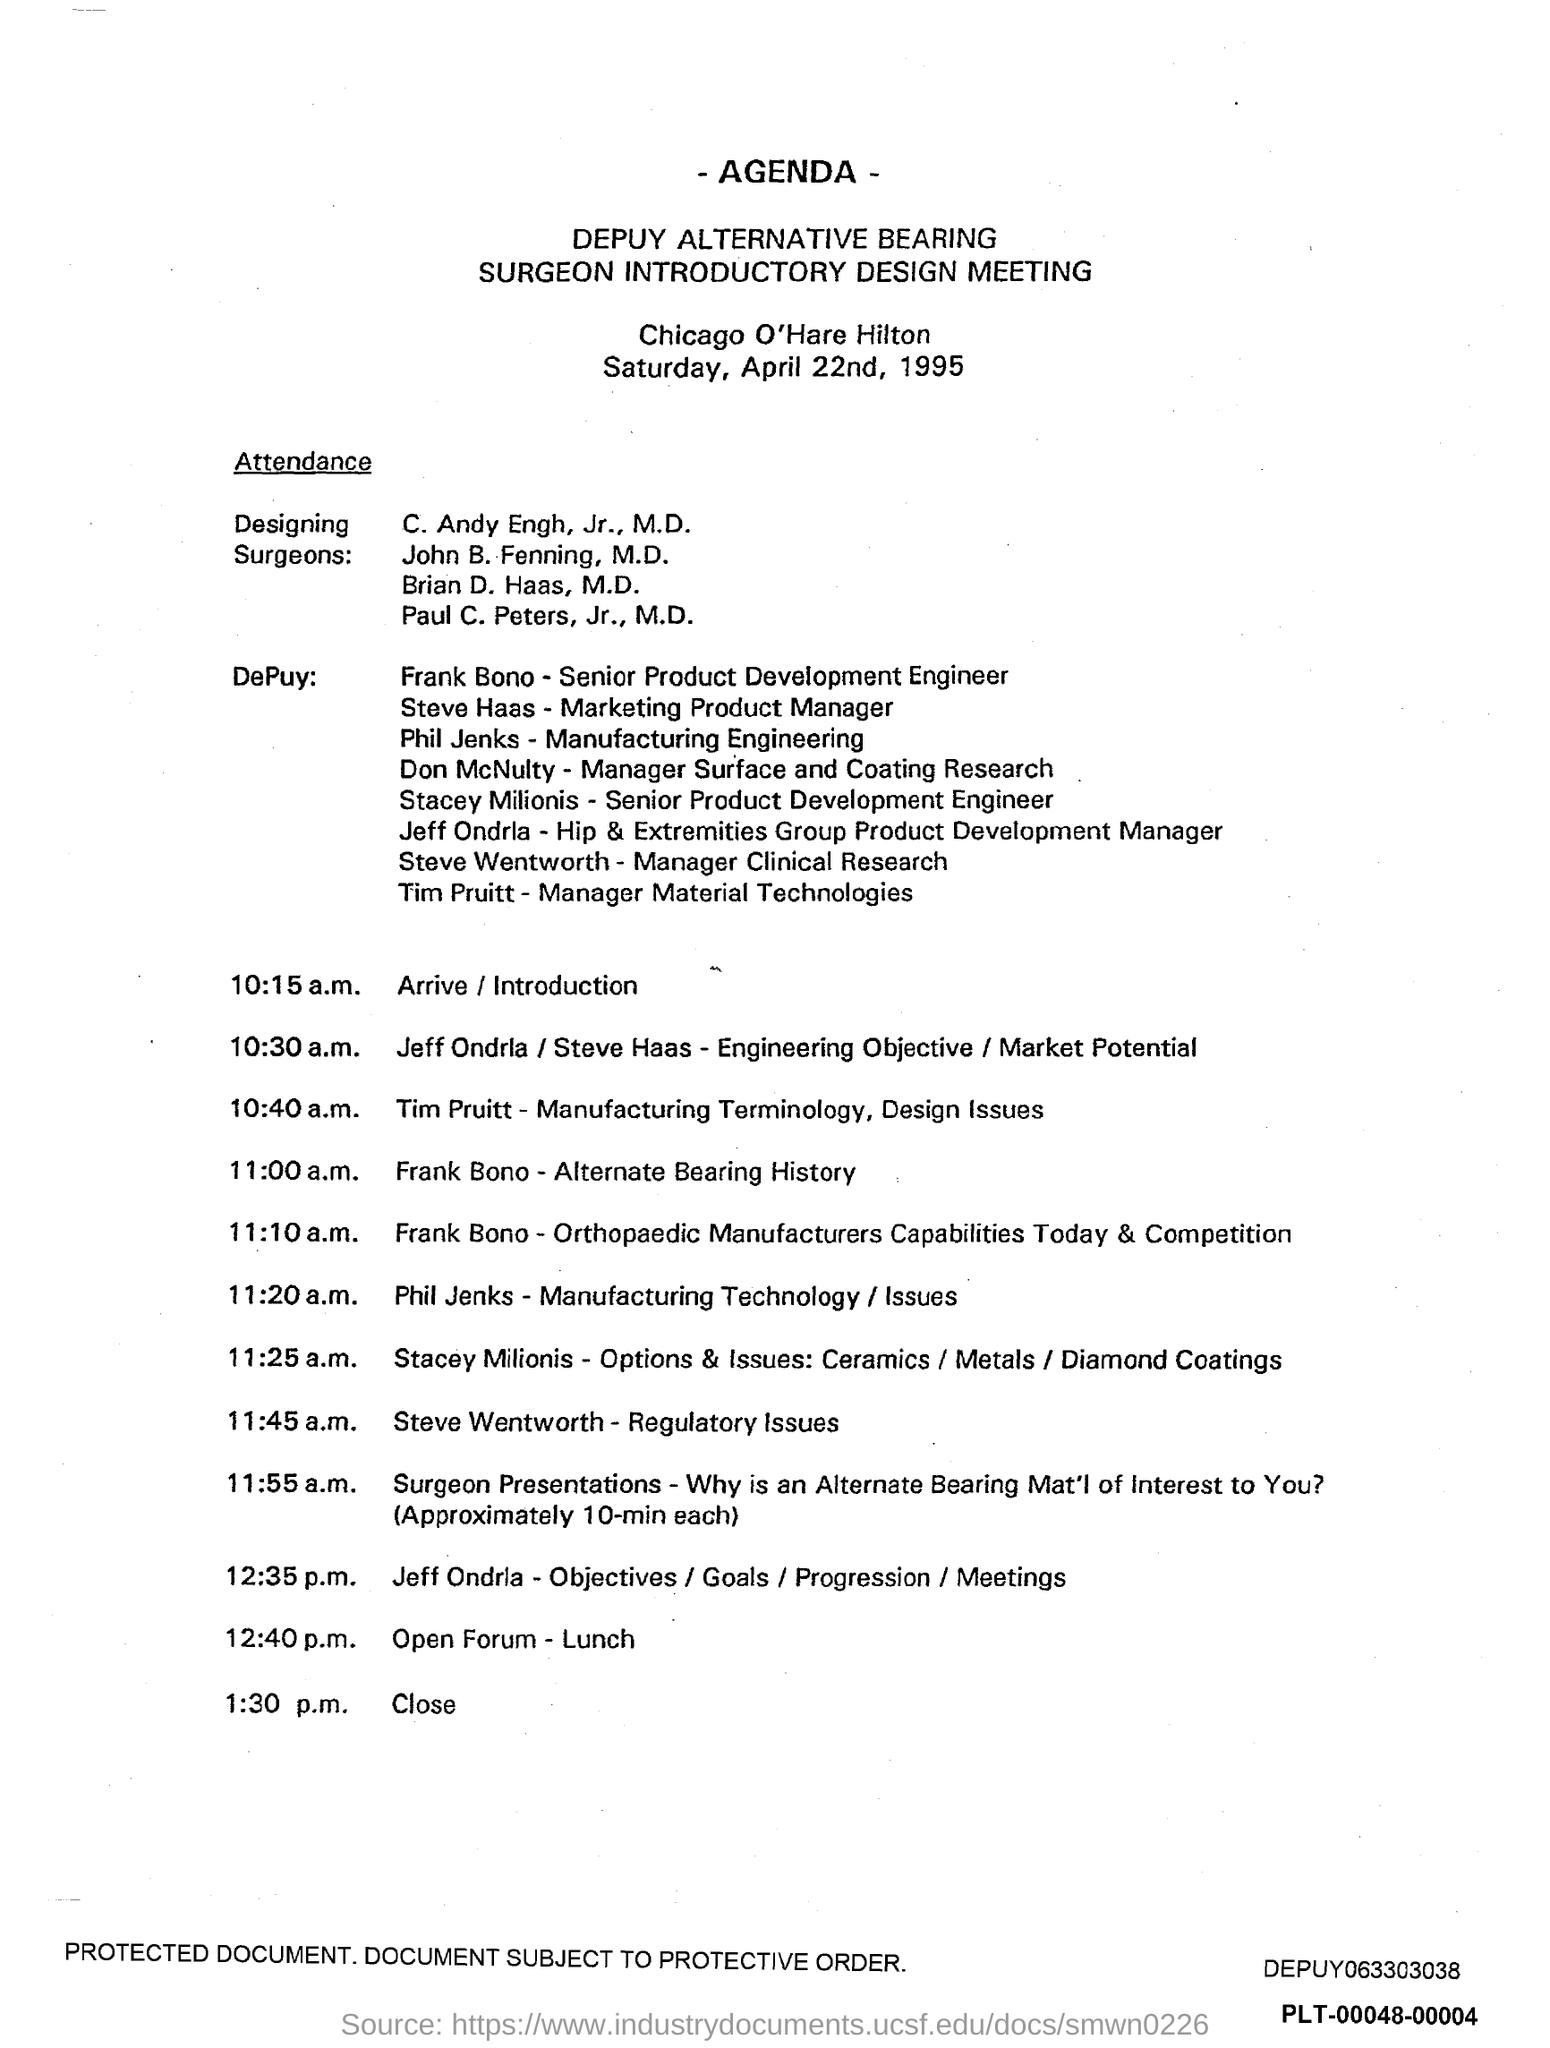What is the heading at top of the page ?
Keep it short and to the point. Agenda. What is the position of frank bono ?
Offer a very short reply. Senior Product Development Engineer. What is the position of steve haas ?
Offer a very short reply. Marketing Product manager. What is the position of phil jenks ?
Make the answer very short. Manufacturing Engineering. What is the position of don mcnulty ?
Your answer should be very brief. Manager surface and Coating research. What is the position of stacey milionis ?
Your response must be concise. Senior Product development Engineer. What is the position of steve wentworth ?
Your answer should be compact. Manager Clinical Research. What is the time scheduled for close ?
Keep it short and to the point. 1:30 p.m. What is the time scheduled for open forum- lunch?
Give a very brief answer. 12:40 p.m. 